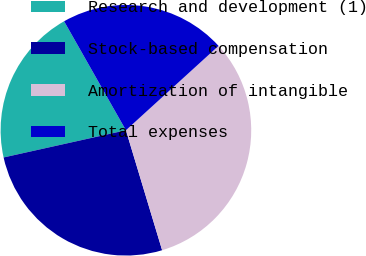Convert chart. <chart><loc_0><loc_0><loc_500><loc_500><pie_chart><fcel>Research and development (1)<fcel>Stock-based compensation<fcel>Amortization of intangible<fcel>Total expenses<nl><fcel>20.27%<fcel>26.18%<fcel>32.09%<fcel>21.45%<nl></chart> 